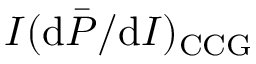Convert formula to latex. <formula><loc_0><loc_0><loc_500><loc_500>I ( d \bar { P } / d I ) _ { C C G }</formula> 